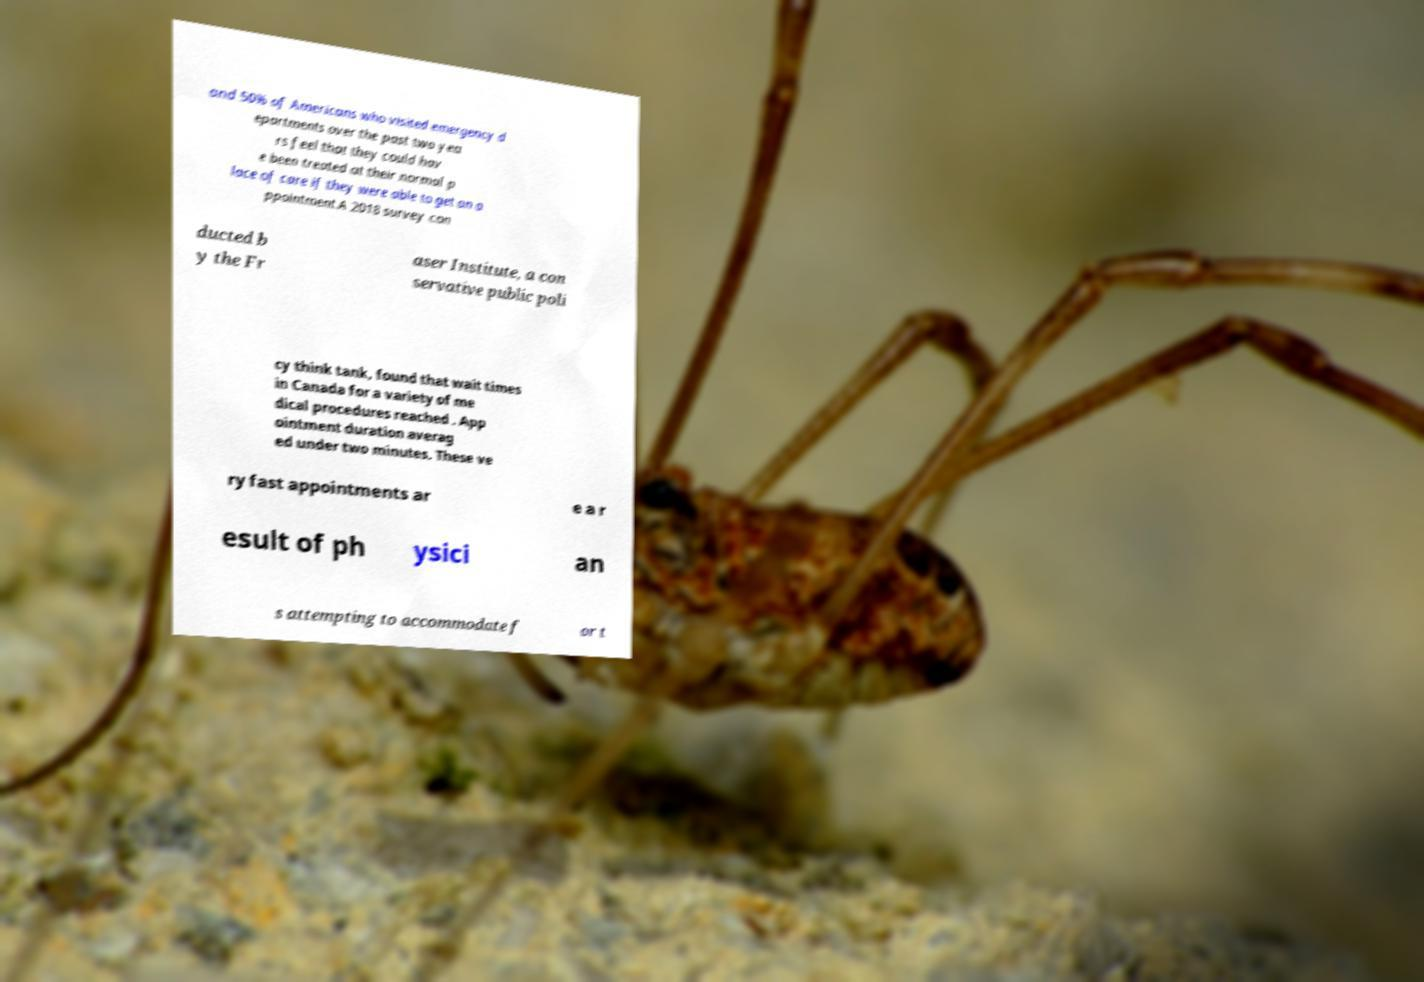Can you read and provide the text displayed in the image?This photo seems to have some interesting text. Can you extract and type it out for me? and 50% of Americans who visited emergency d epartments over the past two yea rs feel that they could hav e been treated at their normal p lace of care if they were able to get an a ppointment.A 2018 survey con ducted b y the Fr aser Institute, a con servative public poli cy think tank, found that wait times in Canada for a variety of me dical procedures reached . App ointment duration averag ed under two minutes. These ve ry fast appointments ar e a r esult of ph ysici an s attempting to accommodate f or t 